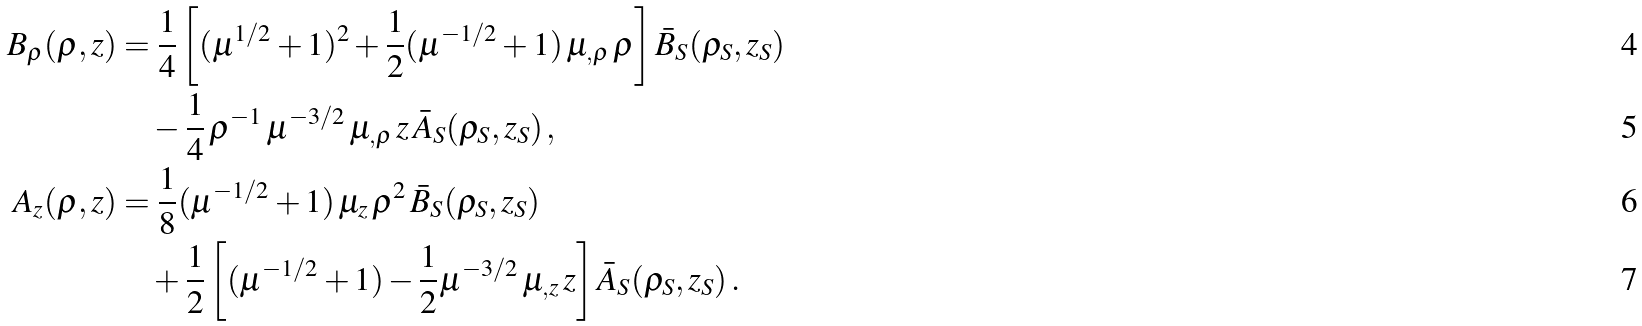Convert formula to latex. <formula><loc_0><loc_0><loc_500><loc_500>B _ { \rho } ( \rho , z ) & = \frac { 1 } { 4 } \left [ ( \mu ^ { 1 / 2 } + 1 ) ^ { 2 } + \frac { 1 } { 2 } ( \mu ^ { - 1 / 2 } + 1 ) \, \mu _ { , \rho } \, \rho \right ] \bar { B } _ { S } ( \rho _ { S } , z _ { S } ) \\ & \quad - \frac { 1 } { 4 } \, \rho ^ { - 1 } \, \mu ^ { - 3 / 2 } \, \mu _ { , \rho } \, z \, \bar { A } _ { S } ( \rho _ { S } , z _ { S } ) \, , \\ A _ { z } ( \rho , z ) & = \frac { 1 } { 8 } ( \mu ^ { - 1 / 2 } + 1 ) \, \mu _ { z } \, \rho ^ { 2 } \, \bar { B } _ { S } ( \rho _ { S } , z _ { S } ) \\ & \quad + \frac { 1 } { 2 } \left [ ( \mu ^ { - 1 / 2 } + 1 ) - \frac { 1 } { 2 } \mu ^ { - 3 / 2 } \, \mu _ { , z } \, z \right ] \bar { A } _ { S } ( \rho _ { S } , z _ { S } ) \, .</formula> 